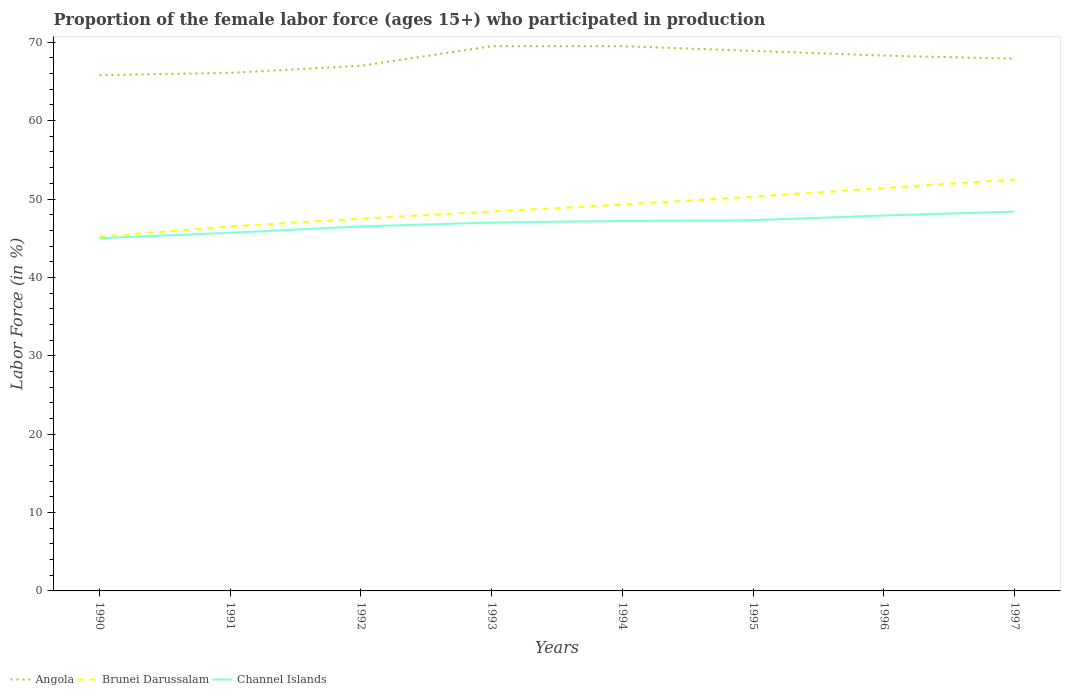How many different coloured lines are there?
Your answer should be very brief. 3. Across all years, what is the maximum proportion of the female labor force who participated in production in Angola?
Keep it short and to the point. 65.8. What is the total proportion of the female labor force who participated in production in Angola in the graph?
Offer a terse response. -3.7. What is the difference between the highest and the second highest proportion of the female labor force who participated in production in Brunei Darussalam?
Provide a short and direct response. 7.3. Is the proportion of the female labor force who participated in production in Channel Islands strictly greater than the proportion of the female labor force who participated in production in Angola over the years?
Ensure brevity in your answer.  Yes. How many years are there in the graph?
Your answer should be compact. 8. What is the difference between two consecutive major ticks on the Y-axis?
Your response must be concise. 10. Are the values on the major ticks of Y-axis written in scientific E-notation?
Give a very brief answer. No. Does the graph contain grids?
Your response must be concise. No. How many legend labels are there?
Make the answer very short. 3. How are the legend labels stacked?
Offer a very short reply. Horizontal. What is the title of the graph?
Offer a terse response. Proportion of the female labor force (ages 15+) who participated in production. Does "Andorra" appear as one of the legend labels in the graph?
Offer a very short reply. No. What is the label or title of the X-axis?
Give a very brief answer. Years. What is the Labor Force (in %) of Angola in 1990?
Your response must be concise. 65.8. What is the Labor Force (in %) of Brunei Darussalam in 1990?
Offer a terse response. 45.2. What is the Labor Force (in %) of Angola in 1991?
Make the answer very short. 66.1. What is the Labor Force (in %) in Brunei Darussalam in 1991?
Ensure brevity in your answer.  46.5. What is the Labor Force (in %) of Channel Islands in 1991?
Your answer should be very brief. 45.7. What is the Labor Force (in %) of Brunei Darussalam in 1992?
Make the answer very short. 47.5. What is the Labor Force (in %) in Channel Islands in 1992?
Your answer should be very brief. 46.5. What is the Labor Force (in %) in Angola in 1993?
Your answer should be compact. 69.5. What is the Labor Force (in %) in Brunei Darussalam in 1993?
Provide a short and direct response. 48.4. What is the Labor Force (in %) of Angola in 1994?
Make the answer very short. 69.5. What is the Labor Force (in %) of Brunei Darussalam in 1994?
Your answer should be very brief. 49.3. What is the Labor Force (in %) in Channel Islands in 1994?
Offer a terse response. 47.2. What is the Labor Force (in %) of Angola in 1995?
Keep it short and to the point. 68.9. What is the Labor Force (in %) in Brunei Darussalam in 1995?
Your response must be concise. 50.3. What is the Labor Force (in %) of Channel Islands in 1995?
Your answer should be very brief. 47.3. What is the Labor Force (in %) in Angola in 1996?
Keep it short and to the point. 68.3. What is the Labor Force (in %) in Brunei Darussalam in 1996?
Ensure brevity in your answer.  51.4. What is the Labor Force (in %) of Channel Islands in 1996?
Make the answer very short. 47.9. What is the Labor Force (in %) in Angola in 1997?
Keep it short and to the point. 67.9. What is the Labor Force (in %) in Brunei Darussalam in 1997?
Make the answer very short. 52.5. What is the Labor Force (in %) of Channel Islands in 1997?
Offer a terse response. 48.4. Across all years, what is the maximum Labor Force (in %) in Angola?
Give a very brief answer. 69.5. Across all years, what is the maximum Labor Force (in %) in Brunei Darussalam?
Keep it short and to the point. 52.5. Across all years, what is the maximum Labor Force (in %) of Channel Islands?
Your response must be concise. 48.4. Across all years, what is the minimum Labor Force (in %) of Angola?
Provide a succinct answer. 65.8. Across all years, what is the minimum Labor Force (in %) of Brunei Darussalam?
Your answer should be compact. 45.2. What is the total Labor Force (in %) of Angola in the graph?
Offer a terse response. 543. What is the total Labor Force (in %) in Brunei Darussalam in the graph?
Provide a succinct answer. 391.1. What is the total Labor Force (in %) of Channel Islands in the graph?
Ensure brevity in your answer.  375. What is the difference between the Labor Force (in %) in Channel Islands in 1990 and that in 1991?
Your answer should be compact. -0.7. What is the difference between the Labor Force (in %) in Angola in 1990 and that in 1992?
Keep it short and to the point. -1.2. What is the difference between the Labor Force (in %) in Channel Islands in 1990 and that in 1992?
Provide a short and direct response. -1.5. What is the difference between the Labor Force (in %) of Angola in 1990 and that in 1993?
Make the answer very short. -3.7. What is the difference between the Labor Force (in %) in Channel Islands in 1990 and that in 1993?
Your answer should be compact. -2. What is the difference between the Labor Force (in %) of Channel Islands in 1990 and that in 1994?
Provide a succinct answer. -2.2. What is the difference between the Labor Force (in %) of Channel Islands in 1990 and that in 1996?
Your response must be concise. -2.9. What is the difference between the Labor Force (in %) of Brunei Darussalam in 1991 and that in 1992?
Your answer should be compact. -1. What is the difference between the Labor Force (in %) in Channel Islands in 1991 and that in 1992?
Ensure brevity in your answer.  -0.8. What is the difference between the Labor Force (in %) in Brunei Darussalam in 1991 and that in 1993?
Your answer should be compact. -1.9. What is the difference between the Labor Force (in %) in Channel Islands in 1991 and that in 1993?
Provide a short and direct response. -1.3. What is the difference between the Labor Force (in %) of Angola in 1991 and that in 1994?
Provide a succinct answer. -3.4. What is the difference between the Labor Force (in %) of Brunei Darussalam in 1991 and that in 1995?
Your answer should be compact. -3.8. What is the difference between the Labor Force (in %) of Channel Islands in 1991 and that in 1996?
Offer a very short reply. -2.2. What is the difference between the Labor Force (in %) in Channel Islands in 1991 and that in 1997?
Provide a succinct answer. -2.7. What is the difference between the Labor Force (in %) of Angola in 1992 and that in 1993?
Provide a short and direct response. -2.5. What is the difference between the Labor Force (in %) in Brunei Darussalam in 1992 and that in 1993?
Ensure brevity in your answer.  -0.9. What is the difference between the Labor Force (in %) of Channel Islands in 1992 and that in 1993?
Make the answer very short. -0.5. What is the difference between the Labor Force (in %) in Brunei Darussalam in 1992 and that in 1995?
Offer a terse response. -2.8. What is the difference between the Labor Force (in %) in Channel Islands in 1992 and that in 1995?
Ensure brevity in your answer.  -0.8. What is the difference between the Labor Force (in %) of Angola in 1992 and that in 1996?
Offer a terse response. -1.3. What is the difference between the Labor Force (in %) of Channel Islands in 1992 and that in 1996?
Offer a very short reply. -1.4. What is the difference between the Labor Force (in %) of Brunei Darussalam in 1992 and that in 1997?
Give a very brief answer. -5. What is the difference between the Labor Force (in %) of Brunei Darussalam in 1993 and that in 1995?
Your response must be concise. -1.9. What is the difference between the Labor Force (in %) of Channel Islands in 1993 and that in 1995?
Your response must be concise. -0.3. What is the difference between the Labor Force (in %) in Angola in 1993 and that in 1996?
Provide a succinct answer. 1.2. What is the difference between the Labor Force (in %) of Channel Islands in 1993 and that in 1996?
Your answer should be very brief. -0.9. What is the difference between the Labor Force (in %) of Angola in 1993 and that in 1997?
Your answer should be compact. 1.6. What is the difference between the Labor Force (in %) of Angola in 1994 and that in 1995?
Provide a succinct answer. 0.6. What is the difference between the Labor Force (in %) in Brunei Darussalam in 1994 and that in 1995?
Offer a terse response. -1. What is the difference between the Labor Force (in %) of Channel Islands in 1994 and that in 1995?
Your answer should be very brief. -0.1. What is the difference between the Labor Force (in %) of Angola in 1994 and that in 1996?
Your answer should be compact. 1.2. What is the difference between the Labor Force (in %) of Brunei Darussalam in 1994 and that in 1996?
Give a very brief answer. -2.1. What is the difference between the Labor Force (in %) in Brunei Darussalam in 1994 and that in 1997?
Your answer should be very brief. -3.2. What is the difference between the Labor Force (in %) of Channel Islands in 1994 and that in 1997?
Make the answer very short. -1.2. What is the difference between the Labor Force (in %) in Brunei Darussalam in 1995 and that in 1997?
Provide a short and direct response. -2.2. What is the difference between the Labor Force (in %) of Channel Islands in 1995 and that in 1997?
Offer a very short reply. -1.1. What is the difference between the Labor Force (in %) in Brunei Darussalam in 1996 and that in 1997?
Make the answer very short. -1.1. What is the difference between the Labor Force (in %) of Angola in 1990 and the Labor Force (in %) of Brunei Darussalam in 1991?
Give a very brief answer. 19.3. What is the difference between the Labor Force (in %) of Angola in 1990 and the Labor Force (in %) of Channel Islands in 1991?
Your response must be concise. 20.1. What is the difference between the Labor Force (in %) of Brunei Darussalam in 1990 and the Labor Force (in %) of Channel Islands in 1991?
Provide a short and direct response. -0.5. What is the difference between the Labor Force (in %) of Angola in 1990 and the Labor Force (in %) of Brunei Darussalam in 1992?
Keep it short and to the point. 18.3. What is the difference between the Labor Force (in %) in Angola in 1990 and the Labor Force (in %) in Channel Islands in 1992?
Provide a succinct answer. 19.3. What is the difference between the Labor Force (in %) of Angola in 1990 and the Labor Force (in %) of Brunei Darussalam in 1993?
Provide a succinct answer. 17.4. What is the difference between the Labor Force (in %) of Brunei Darussalam in 1990 and the Labor Force (in %) of Channel Islands in 1993?
Offer a very short reply. -1.8. What is the difference between the Labor Force (in %) of Angola in 1990 and the Labor Force (in %) of Brunei Darussalam in 1995?
Offer a terse response. 15.5. What is the difference between the Labor Force (in %) of Angola in 1990 and the Labor Force (in %) of Brunei Darussalam in 1996?
Make the answer very short. 14.4. What is the difference between the Labor Force (in %) in Angola in 1990 and the Labor Force (in %) in Channel Islands in 1996?
Provide a short and direct response. 17.9. What is the difference between the Labor Force (in %) in Angola in 1990 and the Labor Force (in %) in Brunei Darussalam in 1997?
Keep it short and to the point. 13.3. What is the difference between the Labor Force (in %) of Angola in 1990 and the Labor Force (in %) of Channel Islands in 1997?
Your response must be concise. 17.4. What is the difference between the Labor Force (in %) in Angola in 1991 and the Labor Force (in %) in Brunei Darussalam in 1992?
Keep it short and to the point. 18.6. What is the difference between the Labor Force (in %) of Angola in 1991 and the Labor Force (in %) of Channel Islands in 1992?
Make the answer very short. 19.6. What is the difference between the Labor Force (in %) in Angola in 1991 and the Labor Force (in %) in Channel Islands in 1993?
Offer a very short reply. 19.1. What is the difference between the Labor Force (in %) in Brunei Darussalam in 1991 and the Labor Force (in %) in Channel Islands in 1994?
Keep it short and to the point. -0.7. What is the difference between the Labor Force (in %) of Angola in 1991 and the Labor Force (in %) of Brunei Darussalam in 1995?
Offer a terse response. 15.8. What is the difference between the Labor Force (in %) of Brunei Darussalam in 1991 and the Labor Force (in %) of Channel Islands in 1995?
Keep it short and to the point. -0.8. What is the difference between the Labor Force (in %) of Angola in 1991 and the Labor Force (in %) of Brunei Darussalam in 1997?
Provide a succinct answer. 13.6. What is the difference between the Labor Force (in %) in Angola in 1991 and the Labor Force (in %) in Channel Islands in 1997?
Make the answer very short. 17.7. What is the difference between the Labor Force (in %) of Angola in 1992 and the Labor Force (in %) of Brunei Darussalam in 1993?
Offer a very short reply. 18.6. What is the difference between the Labor Force (in %) in Angola in 1992 and the Labor Force (in %) in Channel Islands in 1993?
Your answer should be compact. 20. What is the difference between the Labor Force (in %) of Angola in 1992 and the Labor Force (in %) of Brunei Darussalam in 1994?
Provide a succinct answer. 17.7. What is the difference between the Labor Force (in %) in Angola in 1992 and the Labor Force (in %) in Channel Islands in 1994?
Your response must be concise. 19.8. What is the difference between the Labor Force (in %) of Brunei Darussalam in 1992 and the Labor Force (in %) of Channel Islands in 1994?
Offer a terse response. 0.3. What is the difference between the Labor Force (in %) of Angola in 1992 and the Labor Force (in %) of Brunei Darussalam in 1995?
Your response must be concise. 16.7. What is the difference between the Labor Force (in %) in Brunei Darussalam in 1992 and the Labor Force (in %) in Channel Islands in 1995?
Your answer should be compact. 0.2. What is the difference between the Labor Force (in %) of Angola in 1993 and the Labor Force (in %) of Brunei Darussalam in 1994?
Provide a short and direct response. 20.2. What is the difference between the Labor Force (in %) in Angola in 1993 and the Labor Force (in %) in Channel Islands in 1994?
Provide a succinct answer. 22.3. What is the difference between the Labor Force (in %) in Brunei Darussalam in 1993 and the Labor Force (in %) in Channel Islands in 1995?
Your response must be concise. 1.1. What is the difference between the Labor Force (in %) of Angola in 1993 and the Labor Force (in %) of Channel Islands in 1996?
Offer a very short reply. 21.6. What is the difference between the Labor Force (in %) in Angola in 1993 and the Labor Force (in %) in Channel Islands in 1997?
Ensure brevity in your answer.  21.1. What is the difference between the Labor Force (in %) in Brunei Darussalam in 1993 and the Labor Force (in %) in Channel Islands in 1997?
Keep it short and to the point. 0. What is the difference between the Labor Force (in %) in Angola in 1994 and the Labor Force (in %) in Brunei Darussalam in 1995?
Offer a terse response. 19.2. What is the difference between the Labor Force (in %) of Angola in 1994 and the Labor Force (in %) of Brunei Darussalam in 1996?
Keep it short and to the point. 18.1. What is the difference between the Labor Force (in %) of Angola in 1994 and the Labor Force (in %) of Channel Islands in 1996?
Your response must be concise. 21.6. What is the difference between the Labor Force (in %) of Brunei Darussalam in 1994 and the Labor Force (in %) of Channel Islands in 1996?
Offer a very short reply. 1.4. What is the difference between the Labor Force (in %) of Angola in 1994 and the Labor Force (in %) of Brunei Darussalam in 1997?
Ensure brevity in your answer.  17. What is the difference between the Labor Force (in %) in Angola in 1994 and the Labor Force (in %) in Channel Islands in 1997?
Your response must be concise. 21.1. What is the difference between the Labor Force (in %) in Brunei Darussalam in 1995 and the Labor Force (in %) in Channel Islands in 1996?
Your response must be concise. 2.4. What is the difference between the Labor Force (in %) of Brunei Darussalam in 1995 and the Labor Force (in %) of Channel Islands in 1997?
Offer a terse response. 1.9. What is the average Labor Force (in %) in Angola per year?
Your answer should be compact. 67.88. What is the average Labor Force (in %) of Brunei Darussalam per year?
Keep it short and to the point. 48.89. What is the average Labor Force (in %) in Channel Islands per year?
Provide a succinct answer. 46.88. In the year 1990, what is the difference between the Labor Force (in %) of Angola and Labor Force (in %) of Brunei Darussalam?
Make the answer very short. 20.6. In the year 1990, what is the difference between the Labor Force (in %) in Angola and Labor Force (in %) in Channel Islands?
Provide a succinct answer. 20.8. In the year 1990, what is the difference between the Labor Force (in %) in Brunei Darussalam and Labor Force (in %) in Channel Islands?
Your answer should be compact. 0.2. In the year 1991, what is the difference between the Labor Force (in %) of Angola and Labor Force (in %) of Brunei Darussalam?
Ensure brevity in your answer.  19.6. In the year 1991, what is the difference between the Labor Force (in %) of Angola and Labor Force (in %) of Channel Islands?
Keep it short and to the point. 20.4. In the year 1991, what is the difference between the Labor Force (in %) in Brunei Darussalam and Labor Force (in %) in Channel Islands?
Your answer should be very brief. 0.8. In the year 1992, what is the difference between the Labor Force (in %) in Angola and Labor Force (in %) in Brunei Darussalam?
Your answer should be compact. 19.5. In the year 1993, what is the difference between the Labor Force (in %) of Angola and Labor Force (in %) of Brunei Darussalam?
Give a very brief answer. 21.1. In the year 1994, what is the difference between the Labor Force (in %) of Angola and Labor Force (in %) of Brunei Darussalam?
Give a very brief answer. 20.2. In the year 1994, what is the difference between the Labor Force (in %) of Angola and Labor Force (in %) of Channel Islands?
Offer a very short reply. 22.3. In the year 1995, what is the difference between the Labor Force (in %) in Angola and Labor Force (in %) in Channel Islands?
Offer a very short reply. 21.6. In the year 1995, what is the difference between the Labor Force (in %) in Brunei Darussalam and Labor Force (in %) in Channel Islands?
Your answer should be very brief. 3. In the year 1996, what is the difference between the Labor Force (in %) in Angola and Labor Force (in %) in Brunei Darussalam?
Keep it short and to the point. 16.9. In the year 1996, what is the difference between the Labor Force (in %) in Angola and Labor Force (in %) in Channel Islands?
Keep it short and to the point. 20.4. In the year 1997, what is the difference between the Labor Force (in %) in Brunei Darussalam and Labor Force (in %) in Channel Islands?
Ensure brevity in your answer.  4.1. What is the ratio of the Labor Force (in %) of Angola in 1990 to that in 1991?
Your answer should be compact. 1. What is the ratio of the Labor Force (in %) of Channel Islands in 1990 to that in 1991?
Your answer should be compact. 0.98. What is the ratio of the Labor Force (in %) of Angola in 1990 to that in 1992?
Ensure brevity in your answer.  0.98. What is the ratio of the Labor Force (in %) in Brunei Darussalam in 1990 to that in 1992?
Your response must be concise. 0.95. What is the ratio of the Labor Force (in %) of Channel Islands in 1990 to that in 1992?
Give a very brief answer. 0.97. What is the ratio of the Labor Force (in %) in Angola in 1990 to that in 1993?
Your response must be concise. 0.95. What is the ratio of the Labor Force (in %) of Brunei Darussalam in 1990 to that in 1993?
Provide a short and direct response. 0.93. What is the ratio of the Labor Force (in %) of Channel Islands in 1990 to that in 1993?
Provide a short and direct response. 0.96. What is the ratio of the Labor Force (in %) of Angola in 1990 to that in 1994?
Provide a succinct answer. 0.95. What is the ratio of the Labor Force (in %) in Brunei Darussalam in 1990 to that in 1994?
Give a very brief answer. 0.92. What is the ratio of the Labor Force (in %) in Channel Islands in 1990 to that in 1994?
Offer a terse response. 0.95. What is the ratio of the Labor Force (in %) in Angola in 1990 to that in 1995?
Make the answer very short. 0.95. What is the ratio of the Labor Force (in %) in Brunei Darussalam in 1990 to that in 1995?
Offer a terse response. 0.9. What is the ratio of the Labor Force (in %) in Channel Islands in 1990 to that in 1995?
Provide a short and direct response. 0.95. What is the ratio of the Labor Force (in %) of Angola in 1990 to that in 1996?
Your answer should be very brief. 0.96. What is the ratio of the Labor Force (in %) of Brunei Darussalam in 1990 to that in 1996?
Your answer should be very brief. 0.88. What is the ratio of the Labor Force (in %) of Channel Islands in 1990 to that in 1996?
Make the answer very short. 0.94. What is the ratio of the Labor Force (in %) in Angola in 1990 to that in 1997?
Offer a very short reply. 0.97. What is the ratio of the Labor Force (in %) in Brunei Darussalam in 1990 to that in 1997?
Offer a very short reply. 0.86. What is the ratio of the Labor Force (in %) of Channel Islands in 1990 to that in 1997?
Your response must be concise. 0.93. What is the ratio of the Labor Force (in %) in Angola in 1991 to that in 1992?
Your answer should be compact. 0.99. What is the ratio of the Labor Force (in %) of Brunei Darussalam in 1991 to that in 1992?
Provide a succinct answer. 0.98. What is the ratio of the Labor Force (in %) in Channel Islands in 1991 to that in 1992?
Offer a very short reply. 0.98. What is the ratio of the Labor Force (in %) of Angola in 1991 to that in 1993?
Give a very brief answer. 0.95. What is the ratio of the Labor Force (in %) in Brunei Darussalam in 1991 to that in 1993?
Your answer should be very brief. 0.96. What is the ratio of the Labor Force (in %) in Channel Islands in 1991 to that in 1993?
Your response must be concise. 0.97. What is the ratio of the Labor Force (in %) of Angola in 1991 to that in 1994?
Provide a succinct answer. 0.95. What is the ratio of the Labor Force (in %) in Brunei Darussalam in 1991 to that in 1994?
Provide a short and direct response. 0.94. What is the ratio of the Labor Force (in %) in Channel Islands in 1991 to that in 1994?
Offer a terse response. 0.97. What is the ratio of the Labor Force (in %) in Angola in 1991 to that in 1995?
Your answer should be very brief. 0.96. What is the ratio of the Labor Force (in %) in Brunei Darussalam in 1991 to that in 1995?
Ensure brevity in your answer.  0.92. What is the ratio of the Labor Force (in %) of Channel Islands in 1991 to that in 1995?
Provide a short and direct response. 0.97. What is the ratio of the Labor Force (in %) in Angola in 1991 to that in 1996?
Provide a succinct answer. 0.97. What is the ratio of the Labor Force (in %) in Brunei Darussalam in 1991 to that in 1996?
Keep it short and to the point. 0.9. What is the ratio of the Labor Force (in %) in Channel Islands in 1991 to that in 1996?
Ensure brevity in your answer.  0.95. What is the ratio of the Labor Force (in %) of Angola in 1991 to that in 1997?
Your answer should be very brief. 0.97. What is the ratio of the Labor Force (in %) in Brunei Darussalam in 1991 to that in 1997?
Provide a short and direct response. 0.89. What is the ratio of the Labor Force (in %) in Channel Islands in 1991 to that in 1997?
Your answer should be compact. 0.94. What is the ratio of the Labor Force (in %) in Angola in 1992 to that in 1993?
Your answer should be compact. 0.96. What is the ratio of the Labor Force (in %) in Brunei Darussalam in 1992 to that in 1993?
Provide a short and direct response. 0.98. What is the ratio of the Labor Force (in %) in Channel Islands in 1992 to that in 1993?
Ensure brevity in your answer.  0.99. What is the ratio of the Labor Force (in %) in Brunei Darussalam in 1992 to that in 1994?
Keep it short and to the point. 0.96. What is the ratio of the Labor Force (in %) of Channel Islands in 1992 to that in 1994?
Keep it short and to the point. 0.99. What is the ratio of the Labor Force (in %) in Angola in 1992 to that in 1995?
Ensure brevity in your answer.  0.97. What is the ratio of the Labor Force (in %) in Brunei Darussalam in 1992 to that in 1995?
Offer a very short reply. 0.94. What is the ratio of the Labor Force (in %) of Channel Islands in 1992 to that in 1995?
Provide a succinct answer. 0.98. What is the ratio of the Labor Force (in %) in Angola in 1992 to that in 1996?
Your response must be concise. 0.98. What is the ratio of the Labor Force (in %) of Brunei Darussalam in 1992 to that in 1996?
Your answer should be very brief. 0.92. What is the ratio of the Labor Force (in %) of Channel Islands in 1992 to that in 1996?
Provide a succinct answer. 0.97. What is the ratio of the Labor Force (in %) of Angola in 1992 to that in 1997?
Ensure brevity in your answer.  0.99. What is the ratio of the Labor Force (in %) of Brunei Darussalam in 1992 to that in 1997?
Ensure brevity in your answer.  0.9. What is the ratio of the Labor Force (in %) in Channel Islands in 1992 to that in 1997?
Your answer should be compact. 0.96. What is the ratio of the Labor Force (in %) of Angola in 1993 to that in 1994?
Offer a very short reply. 1. What is the ratio of the Labor Force (in %) of Brunei Darussalam in 1993 to that in 1994?
Give a very brief answer. 0.98. What is the ratio of the Labor Force (in %) in Angola in 1993 to that in 1995?
Keep it short and to the point. 1.01. What is the ratio of the Labor Force (in %) in Brunei Darussalam in 1993 to that in 1995?
Provide a succinct answer. 0.96. What is the ratio of the Labor Force (in %) of Channel Islands in 1993 to that in 1995?
Give a very brief answer. 0.99. What is the ratio of the Labor Force (in %) of Angola in 1993 to that in 1996?
Offer a terse response. 1.02. What is the ratio of the Labor Force (in %) in Brunei Darussalam in 1993 to that in 1996?
Your answer should be very brief. 0.94. What is the ratio of the Labor Force (in %) in Channel Islands in 1993 to that in 1996?
Offer a terse response. 0.98. What is the ratio of the Labor Force (in %) of Angola in 1993 to that in 1997?
Your answer should be very brief. 1.02. What is the ratio of the Labor Force (in %) of Brunei Darussalam in 1993 to that in 1997?
Give a very brief answer. 0.92. What is the ratio of the Labor Force (in %) of Channel Islands in 1993 to that in 1997?
Offer a very short reply. 0.97. What is the ratio of the Labor Force (in %) in Angola in 1994 to that in 1995?
Keep it short and to the point. 1.01. What is the ratio of the Labor Force (in %) of Brunei Darussalam in 1994 to that in 1995?
Your answer should be compact. 0.98. What is the ratio of the Labor Force (in %) of Angola in 1994 to that in 1996?
Ensure brevity in your answer.  1.02. What is the ratio of the Labor Force (in %) of Brunei Darussalam in 1994 to that in 1996?
Offer a very short reply. 0.96. What is the ratio of the Labor Force (in %) in Channel Islands in 1994 to that in 1996?
Your answer should be very brief. 0.99. What is the ratio of the Labor Force (in %) of Angola in 1994 to that in 1997?
Offer a terse response. 1.02. What is the ratio of the Labor Force (in %) in Brunei Darussalam in 1994 to that in 1997?
Give a very brief answer. 0.94. What is the ratio of the Labor Force (in %) of Channel Islands in 1994 to that in 1997?
Give a very brief answer. 0.98. What is the ratio of the Labor Force (in %) in Angola in 1995 to that in 1996?
Provide a short and direct response. 1.01. What is the ratio of the Labor Force (in %) in Brunei Darussalam in 1995 to that in 1996?
Offer a terse response. 0.98. What is the ratio of the Labor Force (in %) of Channel Islands in 1995 to that in 1996?
Offer a terse response. 0.99. What is the ratio of the Labor Force (in %) in Angola in 1995 to that in 1997?
Provide a succinct answer. 1.01. What is the ratio of the Labor Force (in %) of Brunei Darussalam in 1995 to that in 1997?
Make the answer very short. 0.96. What is the ratio of the Labor Force (in %) in Channel Islands in 1995 to that in 1997?
Offer a very short reply. 0.98. What is the ratio of the Labor Force (in %) in Angola in 1996 to that in 1997?
Provide a succinct answer. 1.01. What is the ratio of the Labor Force (in %) in Brunei Darussalam in 1996 to that in 1997?
Your response must be concise. 0.98. What is the ratio of the Labor Force (in %) in Channel Islands in 1996 to that in 1997?
Provide a short and direct response. 0.99. What is the difference between the highest and the second highest Labor Force (in %) in Channel Islands?
Provide a short and direct response. 0.5. What is the difference between the highest and the lowest Labor Force (in %) of Angola?
Your response must be concise. 3.7. What is the difference between the highest and the lowest Labor Force (in %) in Brunei Darussalam?
Make the answer very short. 7.3. What is the difference between the highest and the lowest Labor Force (in %) of Channel Islands?
Keep it short and to the point. 3.4. 